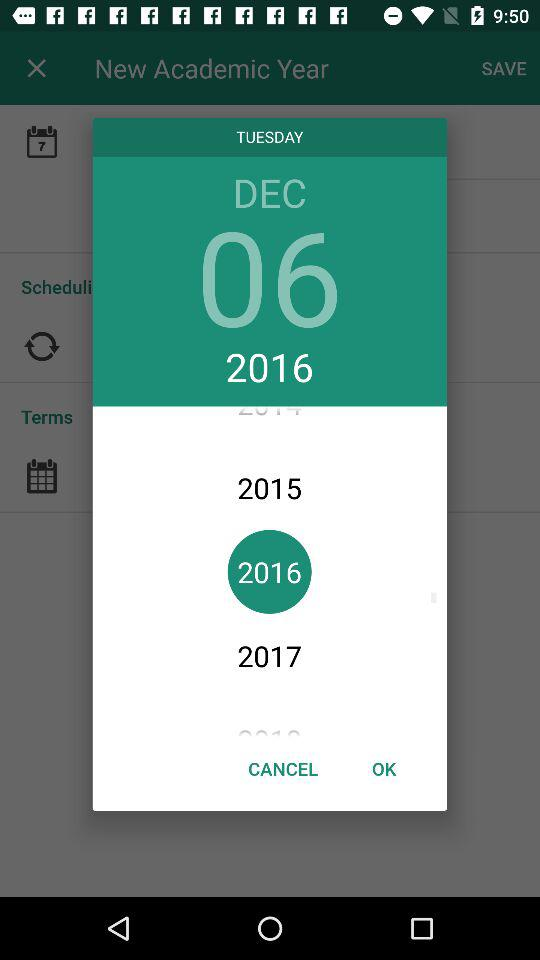What is the selected date? The selected date is Tuesday, December 6, 2016. 